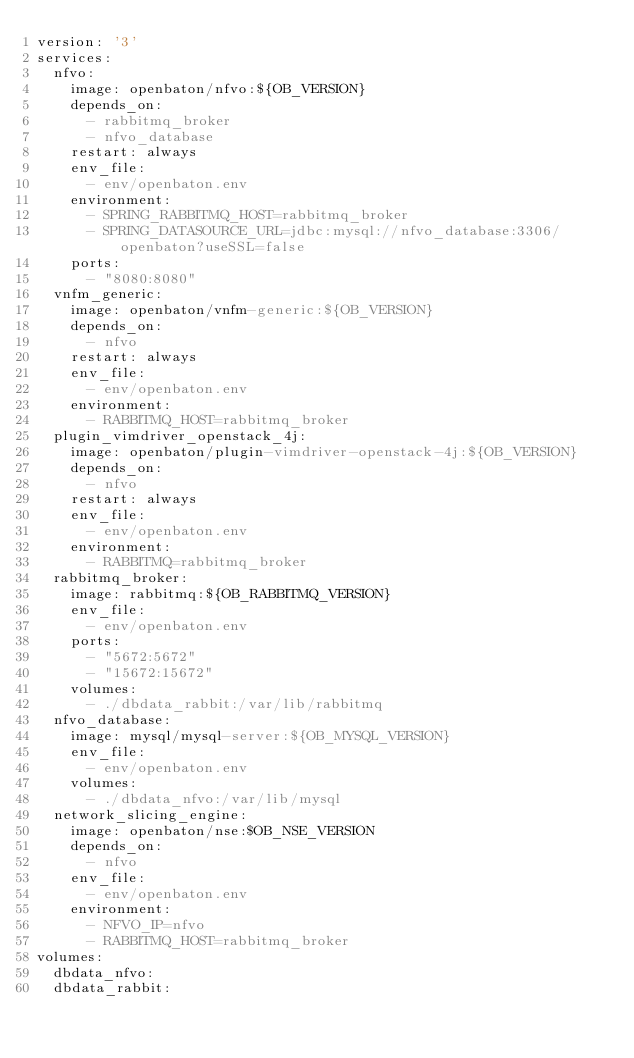<code> <loc_0><loc_0><loc_500><loc_500><_YAML_>version: '3'
services:
  nfvo:
    image: openbaton/nfvo:${OB_VERSION}
    depends_on:
      - rabbitmq_broker
      - nfvo_database
    restart: always
    env_file:
      - env/openbaton.env
    environment:
      - SPRING_RABBITMQ_HOST=rabbitmq_broker
      - SPRING_DATASOURCE_URL=jdbc:mysql://nfvo_database:3306/openbaton?useSSL=false
    ports:
      - "8080:8080"
  vnfm_generic:
    image: openbaton/vnfm-generic:${OB_VERSION}
    depends_on:
      - nfvo
    restart: always
    env_file:
      - env/openbaton.env
    environment:
      - RABBITMQ_HOST=rabbitmq_broker
  plugin_vimdriver_openstack_4j:
    image: openbaton/plugin-vimdriver-openstack-4j:${OB_VERSION}
    depends_on:
      - nfvo
    restart: always
    env_file:
      - env/openbaton.env
    environment:
      - RABBITMQ=rabbitmq_broker
  rabbitmq_broker:
    image: rabbitmq:${OB_RABBITMQ_VERSION}
    env_file:
      - env/openbaton.env
    ports:
      - "5672:5672"
      - "15672:15672"
    volumes:
      - ./dbdata_rabbit:/var/lib/rabbitmq
  nfvo_database:
    image: mysql/mysql-server:${OB_MYSQL_VERSION}
    env_file:
      - env/openbaton.env
    volumes:
      - ./dbdata_nfvo:/var/lib/mysql
  network_slicing_engine:
    image: openbaton/nse:$OB_NSE_VERSION
    depends_on:
      - nfvo
    env_file:
      - env/openbaton.env
    environment:
      - NFVO_IP=nfvo
      - RABBITMQ_HOST=rabbitmq_broker
volumes:
  dbdata_nfvo:
  dbdata_rabbit:
</code> 